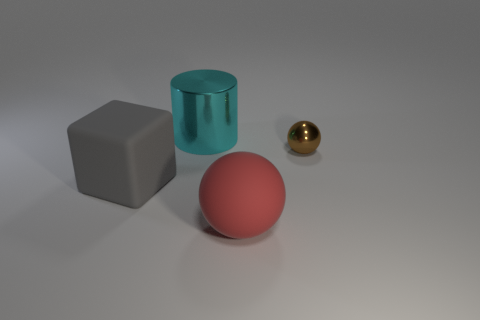Is there any other thing that is the same size as the shiny ball?
Keep it short and to the point. No. Does the large red thing have the same material as the cyan object?
Your answer should be compact. No. What number of purple metal objects are the same shape as the brown metallic object?
Provide a short and direct response. 0. There is a thing that is made of the same material as the brown ball; what is its shape?
Keep it short and to the point. Cylinder. The big rubber thing that is in front of the rubber object on the left side of the red object is what color?
Make the answer very short. Red. What is the material of the object on the right side of the matte thing in front of the big gray thing?
Ensure brevity in your answer.  Metal. What material is the other thing that is the same shape as the big red thing?
Keep it short and to the point. Metal. There is a big object that is behind the matte thing to the left of the large ball; are there any matte objects on the right side of it?
Your answer should be very brief. Yes. What number of big objects are behind the matte sphere and to the right of the large cylinder?
Provide a succinct answer. 0. What shape is the large gray matte object?
Offer a very short reply. Cube. 